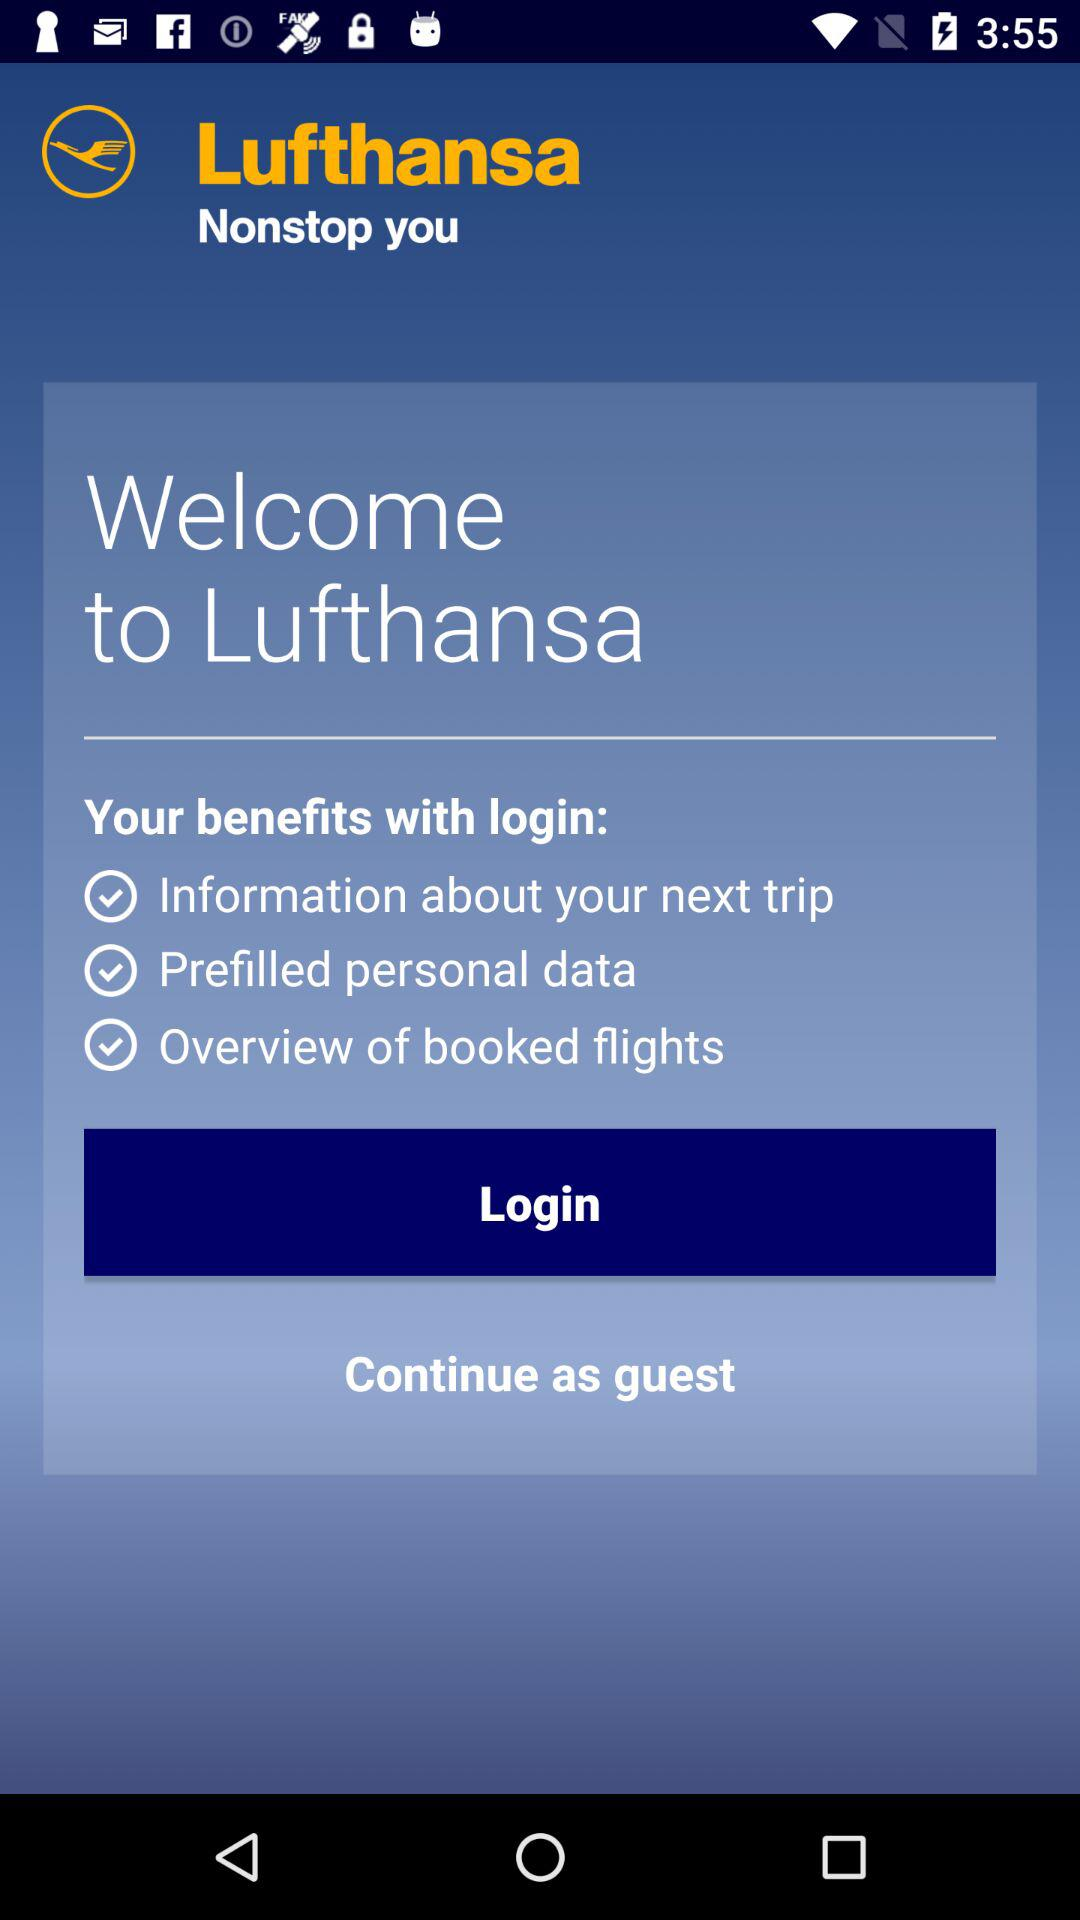What are the benefits of logging in? The benefits of logging in are "Information about your next trip", "Prefilled personal data" and "Overview of booked flights". 